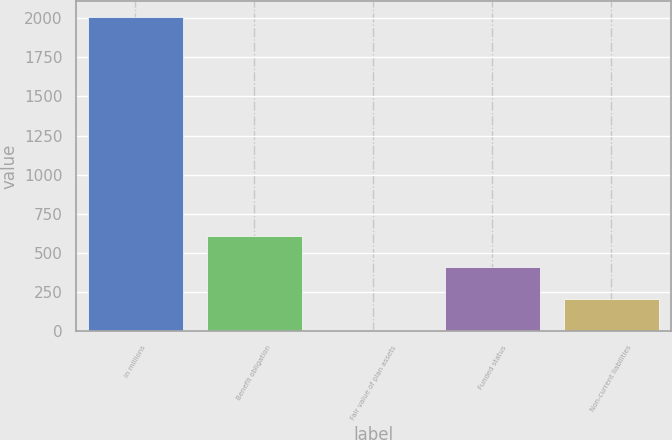Convert chart to OTSL. <chart><loc_0><loc_0><loc_500><loc_500><bar_chart><fcel>in millions<fcel>Benefit obligation<fcel>Fair value of plan assets<fcel>Funded status<fcel>Non-current liabilities<nl><fcel>2010<fcel>608.67<fcel>8.1<fcel>408.48<fcel>208.29<nl></chart> 